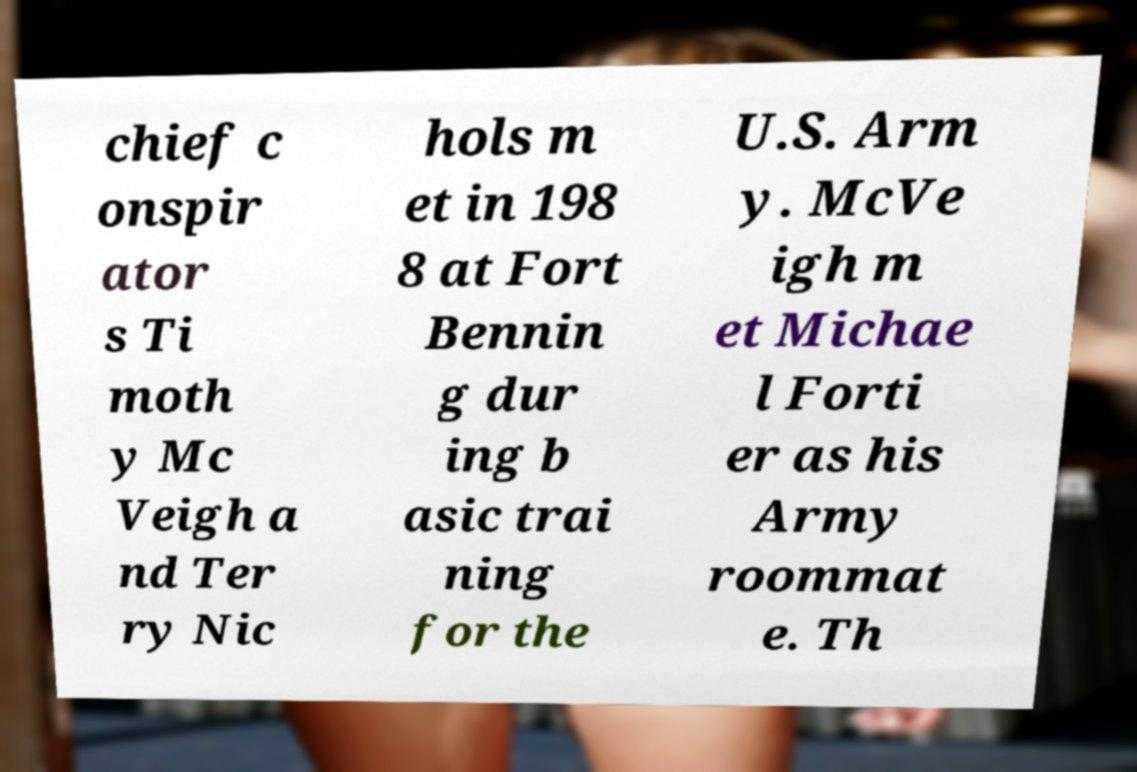There's text embedded in this image that I need extracted. Can you transcribe it verbatim? chief c onspir ator s Ti moth y Mc Veigh a nd Ter ry Nic hols m et in 198 8 at Fort Bennin g dur ing b asic trai ning for the U.S. Arm y. McVe igh m et Michae l Forti er as his Army roommat e. Th 